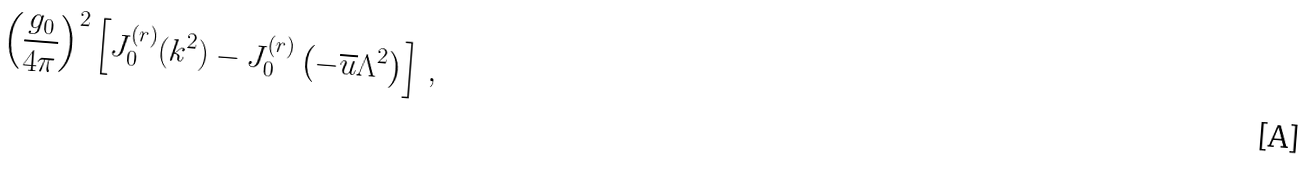Convert formula to latex. <formula><loc_0><loc_0><loc_500><loc_500>\left ( \frac { g _ { 0 } } { 4 \pi } \right ) ^ { 2 } \left [ J ^ { ( r ) } _ { 0 } ( k ^ { 2 } ) - J ^ { ( r ) } _ { 0 } \left ( - \overline { u } \Lambda ^ { 2 } \right ) \right ] \, ,</formula> 